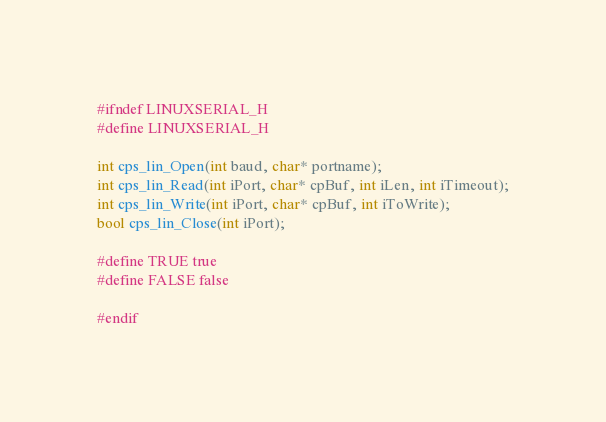Convert code to text. <code><loc_0><loc_0><loc_500><loc_500><_C_>#ifndef LINUXSERIAL_H
#define LINUXSERIAL_H

int cps_lin_Open(int baud, char* portname);
int cps_lin_Read(int iPort, char* cpBuf, int iLen, int iTimeout);
int cps_lin_Write(int iPort, char* cpBuf, int iToWrite);
bool cps_lin_Close(int iPort);

#define TRUE true
#define FALSE false

#endif
</code> 